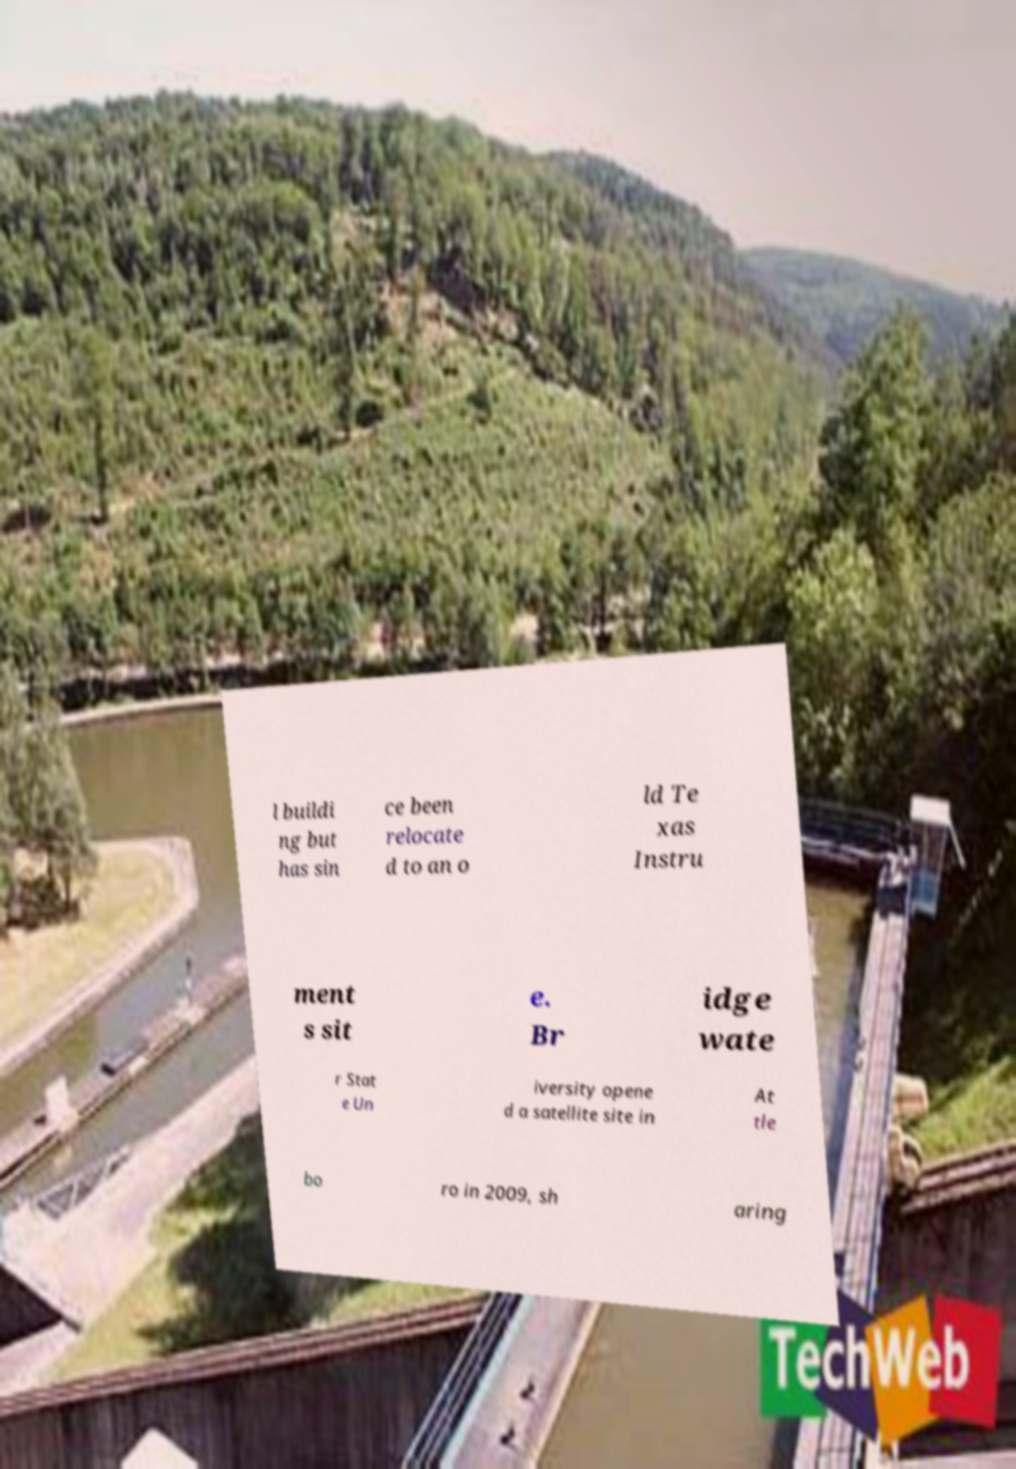Could you extract and type out the text from this image? l buildi ng but has sin ce been relocate d to an o ld Te xas Instru ment s sit e. Br idge wate r Stat e Un iversity opene d a satellite site in At tle bo ro in 2009, sh aring 